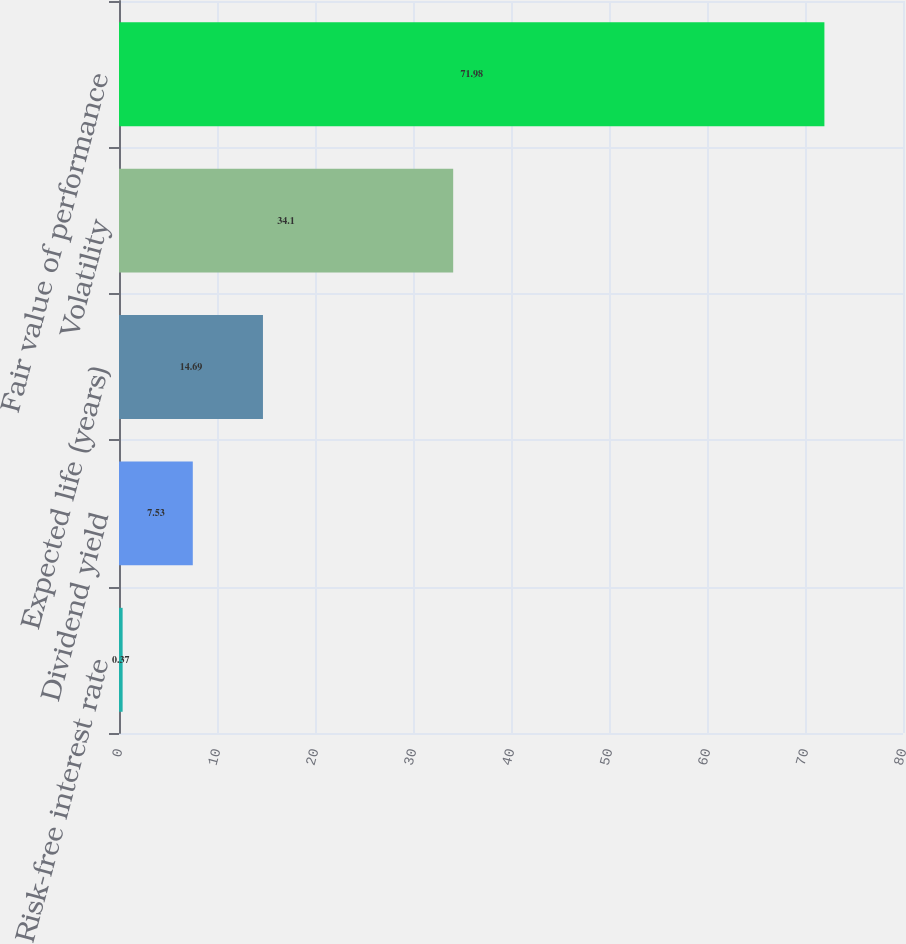<chart> <loc_0><loc_0><loc_500><loc_500><bar_chart><fcel>Risk-free interest rate<fcel>Dividend yield<fcel>Expected life (years)<fcel>Volatility<fcel>Fair value of performance<nl><fcel>0.37<fcel>7.53<fcel>14.69<fcel>34.1<fcel>71.98<nl></chart> 